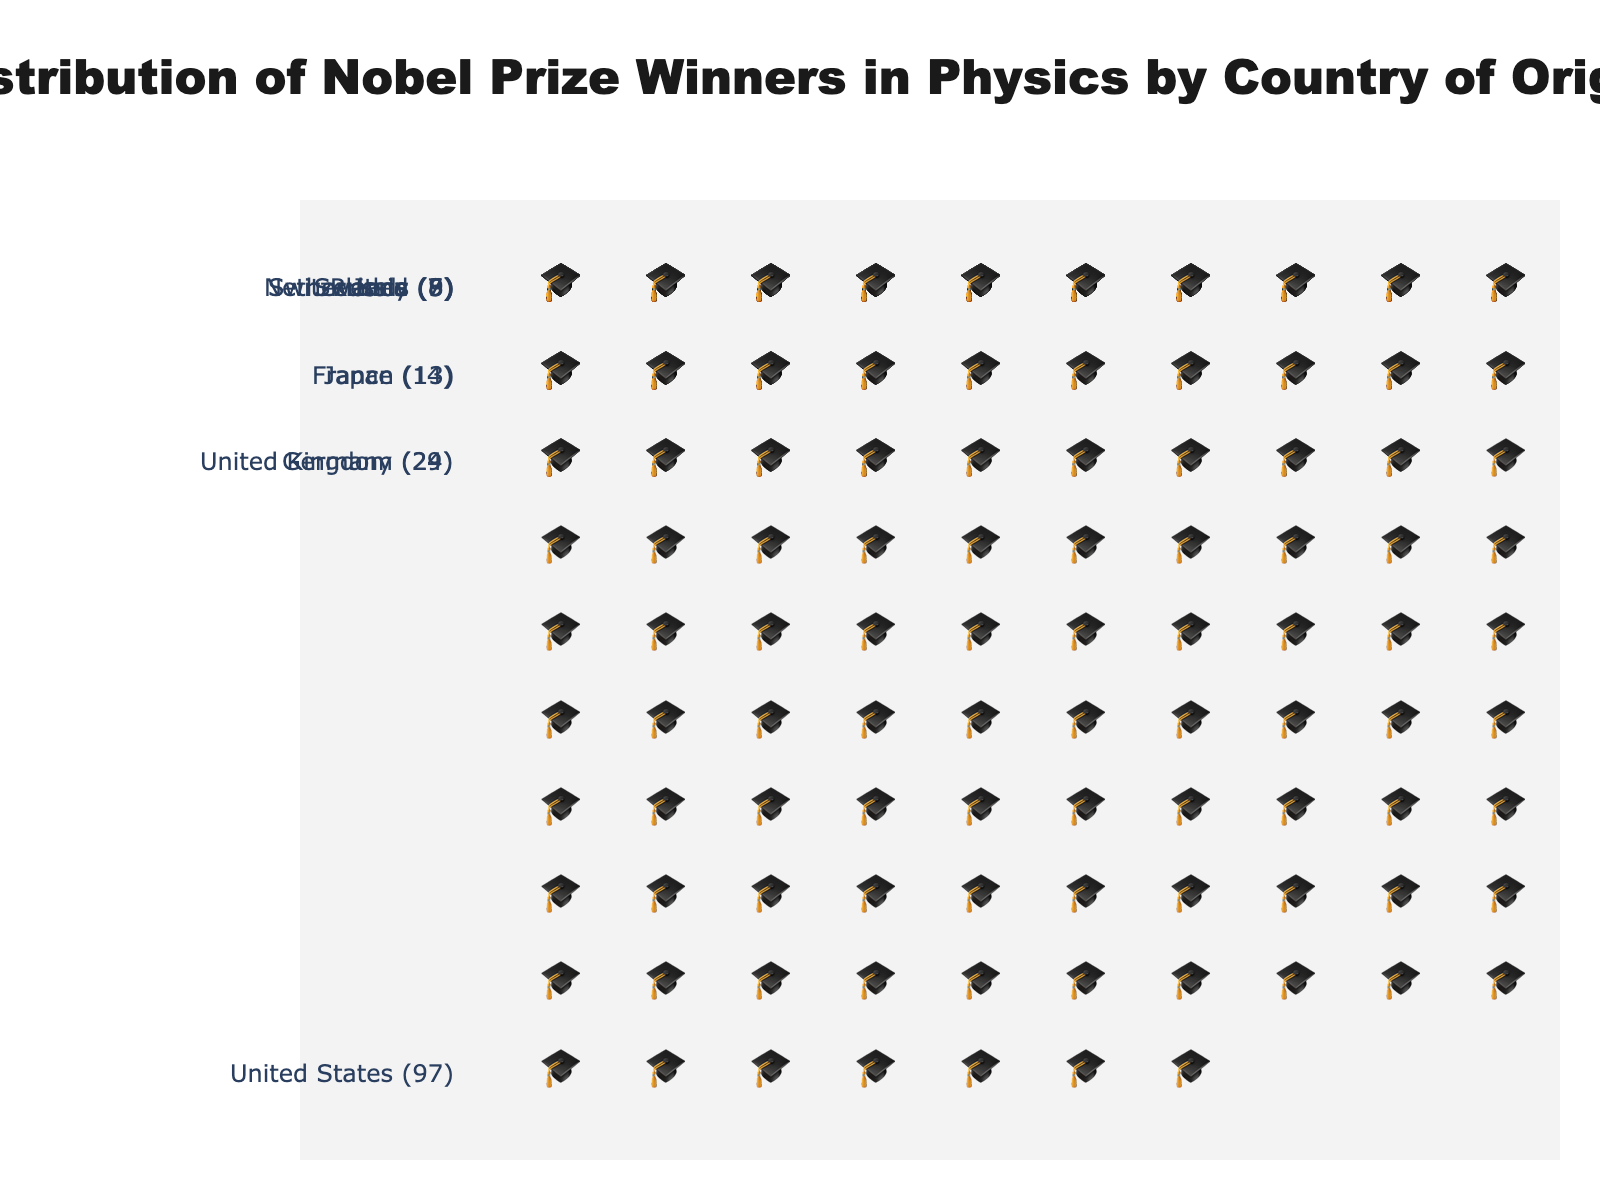What is the total number of Nobel Prize winners in Physics for the top three countries combined? The top three countries by their number of Nobel Prize winners in Physics are the United States with 97, Germany with 29, and the United Kingdom with 24. Adding them together yields 97 + 29 + 24 = 150
Answer: 150 Which country has the highest number of Nobel Prize winners in Physics? Observing the chart, the country represented with the most symbols is the United States, which has 97 Nobel Prize winners.
Answer: United States How many Nobel Prize winners in Physics does Japan have compared to France? According to the plot, Japan has 13 symbols representing their winners, while France has 14 symbols. Therefore, Japan has one fewer winner than France.
Answer: 1 fewer What is the combined number of Nobel Prize winners in Physics for France, Japan, and Netherlands? France has 14, Japan has 13, and the Netherlands has 9 Nobel Prize winners in Physics. Adding them together results in 14 + 13 + 9 = 36
Answer: 36 Which countries have fewer than 10 Nobel Prize winners in Physics and how many are they? From the figure, the countries with fewer than 10 Nobel Prize winners are Switzerland (8), Russia (7), Sweden (6), and Italy (5). Thus, there are four such countries.
Answer: Four countries What is the difference in the number of Nobel Prize winners between the United Kingdom and Germany? The United Kingdom has 24 Nobel Prize winners, and Germany has 29. The difference between these two numbers is 29 - 24 = 5.
Answer: 5 List the number of Nobel Prize winners in Physics for countries that have less than 10 winners in descending order. From the plot, the numbers of winners for countries having less than 10 winners are: Switzerland (8), Russia (7), Sweden (6), and Italy (5).
Answer: Switzerland: 8, Russia: 7, Sweden: 6, Italy: 5 What percentage of the total Nobel Prize winners in Physics come from the United States? The total number of winners is the sum from all countries, which is 97 + 29 + 24 + 14 + 13 + 9 + 8 + 7 + 6 + 5 = 212. The percentage for the United States is (97 / 212) * 100 ≈ 45.75%.
Answer: 45.75% Which country has the closest number of Nobel Prize winners in Physics to the United Kingdom? The United Kingdom has 24 Nobel Prize winners, and comparing this with other countries, Germany (29) is the closest with a difference of 5.
Answer: Germany What is the range of the number of Nobel Prize winners in Physics among the listed countries? The range is found by subtracting the smallest number of winners (Italy with 5) from the largest number of winners (United States with 97). Therefore, the range is 97 - 5 = 92.
Answer: 92 